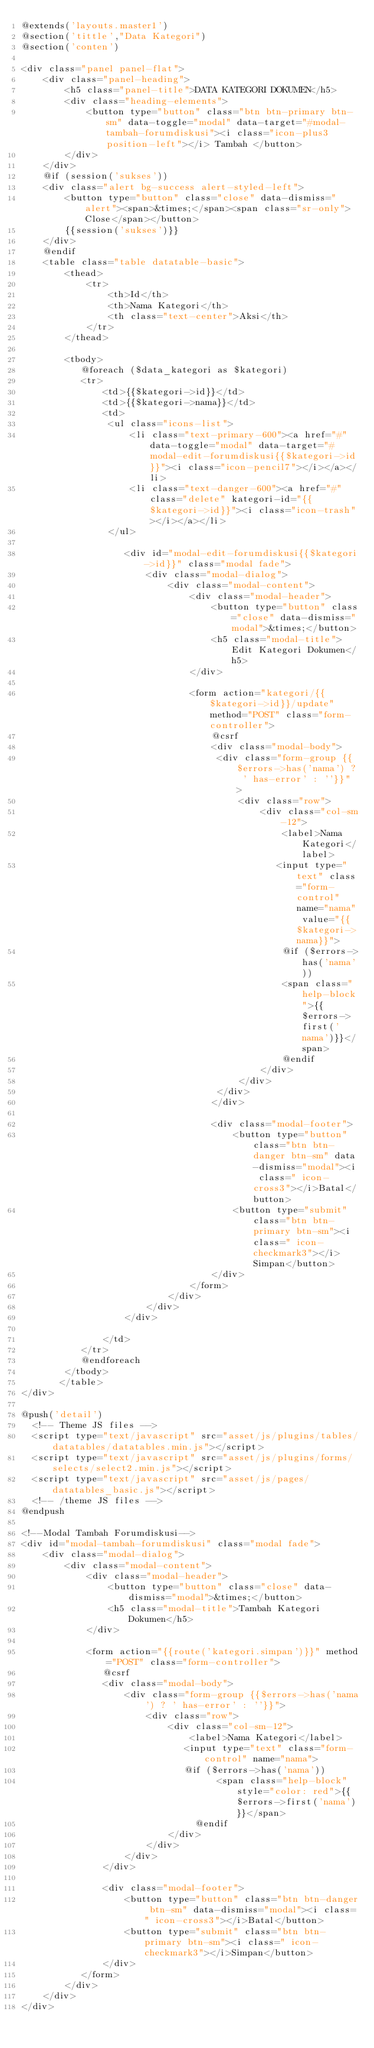<code> <loc_0><loc_0><loc_500><loc_500><_PHP_>@extends('layouts.master1')
@section('tittle',"Data Kategori")
@section('conten')

<div class="panel panel-flat">
    <div class="panel-heading">
        <h5 class="panel-title">DATA KATEGORI DOKUMEN</h5>
        <div class="heading-elements">
            <button type="button" class="btn btn-primary btn-sm" data-toggle="modal" data-target="#modal-tambah-forumdiskusi"><i class="icon-plus3 position-left"></i> Tambah </button>
        </div>
    </div>
    @if (session('sukses'))
    <div class="alert bg-success alert-styled-left">
        <button type="button" class="close" data-dismiss="alert"><span>&times;</span><span class="sr-only">Close</span></button>
        {{session('sukses')}}
    </div> 
    @endif
    <table class="table datatable-basic">
        <thead>
            <tr>
                <th>Id</th>
                <th>Nama Kategori</th>
                <th class="text-center">Aksi</th>
            </tr>
        </thead>
        
        <tbody>
           @foreach ($data_kategori as $kategori)
           <tr>
               <td>{{$kategori->id}}</td>
               <td>{{$kategori->nama}}</td>
               <td>
                <ul class="icons-list">
                    <li class="text-primary-600"><a href="#" data-toggle="modal" data-target="#modal-edit-forumdiskusi{{$kategori->id}}"><i class="icon-pencil7"></i></a></li>
                    <li class="text-danger-600"><a href="#" class="delete" kategori-id="{{$kategori->id}}"><i class="icon-trash"></i></a></li>
                </ul>

                   <div id="modal-edit-forumdiskusi{{$kategori->id}}" class="modal fade">
                       <div class="modal-dialog">
                           <div class="modal-content">
                               <div class="modal-header">
                                   <button type="button" class="close" data-dismiss="modal">&times;</button>
                                   <h5 class="modal-title"> Edit Kategori Dokumen</h5>
                               </div>
                   
                               <form action="kategori/{{$kategori->id}}/update" method="POST" class="form-controller">
                                   @csrf
                                   <div class="modal-body">
                                    <div class="form-group {{$errors->has('nama') ? ' has-error' : ''}}" >
                                        <div class="row">
                                            <div class="col-sm-12">
                                                <label>Nama Kategori</label>
                                               <input type="text" class="form-control" name="nama" value="{{$kategori->nama}}">
                                                @if ($errors->has('nama'))
                                                <span class="help-block">{{$errors->first('nama')}}</span>
                                                @endif
                                            </div>
                                        </div>
                                    </div>
                                   </div>
   
                                   <div class="modal-footer">
                                       <button type="button" class="btn btn-danger btn-sm" data-dismiss="modal"><i class=" icon-cross3"></i>Batal</button> 
                                       <button type="submit" class="btn btn-primary btn-sm"><i class=" icon-checkmark3"></i>Simpan</button> 
                                   </div>
                               </form>
                           </div>
                       </div>
                   </div>
   
               </td>
           </tr>   
           @endforeach
        </tbody>
       </table>
</div>

@push('detail')
  <!-- Theme JS files -->
	<script type="text/javascript" src="asset/js/plugins/tables/datatables/datatables.min.js"></script>
	<script type="text/javascript" src="asset/js/plugins/forms/selects/select2.min.js"></script>
	<script type="text/javascript" src="asset/js/pages/datatables_basic.js"></script>
	<!-- /theme JS files -->
@endpush

<!--Modal Tambah Forumdiskusi-->
<div id="modal-tambah-forumdiskusi" class="modal fade">
    <div class="modal-dialog">
        <div class="modal-content">
            <div class="modal-header">
                <button type="button" class="close" data-dismiss="modal">&times;</button>
                <h5 class="modal-title">Tambah Kategori Dokumen</h5>
            </div>

            <form action="{{route('kategori.simpan')}}" method="POST" class="form-controller">
               @csrf
               <div class="modal-body">
                   <div class="form-group {{$errors->has('nama') ? ' has-error' : ''}}">
                       <div class="row">
                           <div class="col-sm-12">
                               <label>Nama Kategori</label>
                              <input type="text" class="form-control" name="nama">
                              @if ($errors->has('nama'))
                                    <span class="help-block" style="color: red">{{$errors->first('nama')}}</span>
                                @endif
                           </div>
                       </div>
                   </div>
               </div>

               <div class="modal-footer">
                   <button type="button" class="btn btn-danger btn-sm" data-dismiss="modal"><i class=" icon-cross3"></i>Batal</button> 
                   <button type="submit" class="btn btn-primary btn-sm"><i class=" icon-checkmark3"></i>Simpan</button> 
               </div>
           </form>
        </div>
    </div>
</div>
</code> 